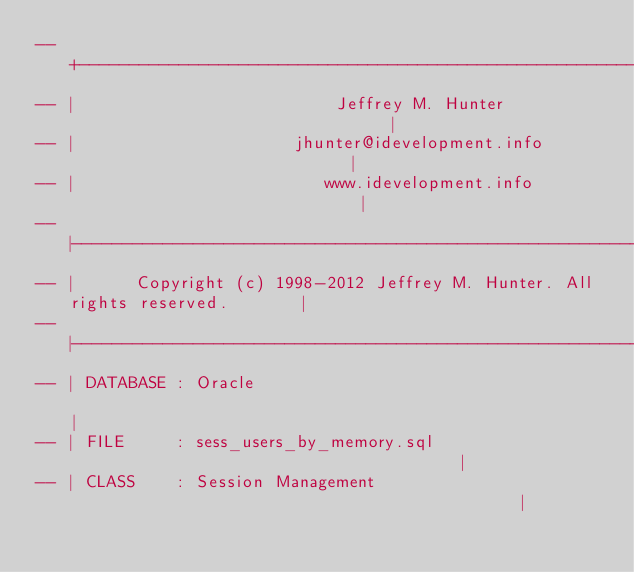<code> <loc_0><loc_0><loc_500><loc_500><_SQL_>-- +----------------------------------------------------------------------------+
-- |                          Jeffrey M. Hunter                                 |
-- |                      jhunter@idevelopment.info                             |
-- |                         www.idevelopment.info                              |
-- |----------------------------------------------------------------------------|
-- |      Copyright (c) 1998-2012 Jeffrey M. Hunter. All rights reserved.       |
-- |----------------------------------------------------------------------------|
-- | DATABASE : Oracle                                                          |
-- | FILE     : sess_users_by_memory.sql                                        |
-- | CLASS    : Session Management                                              |</code> 